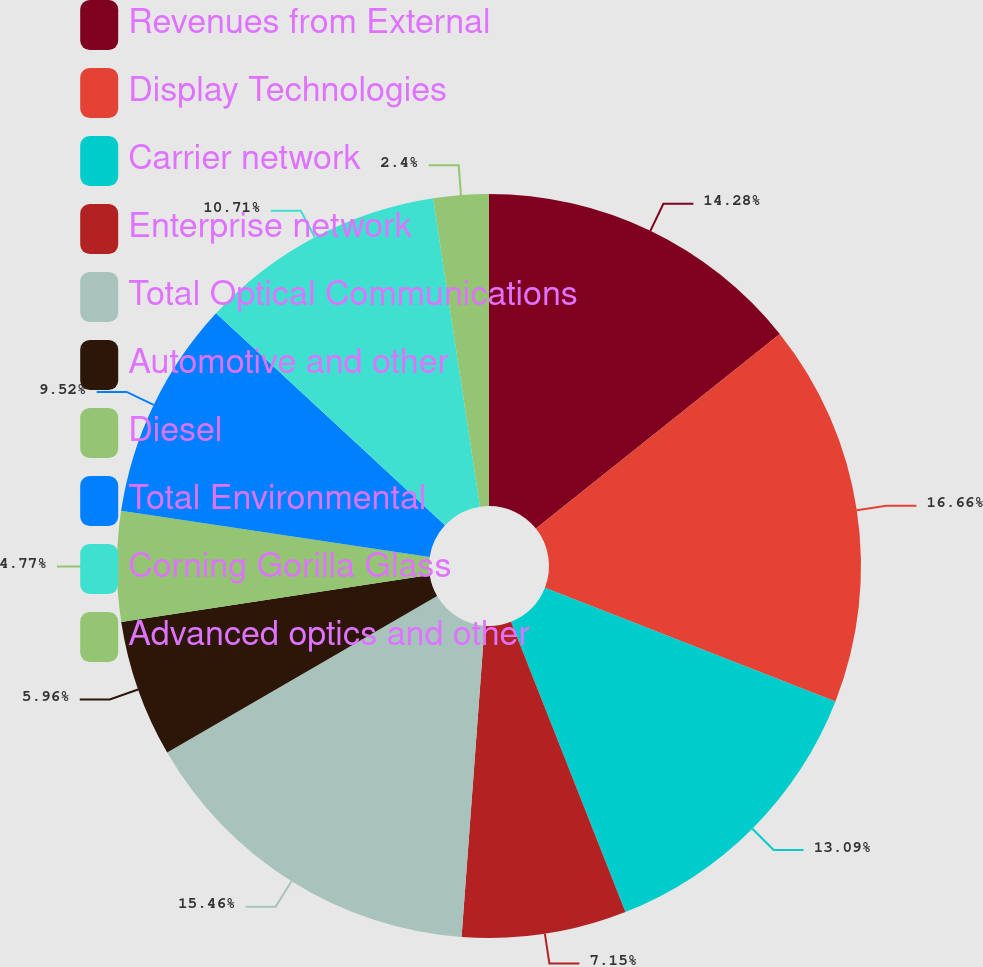Convert chart to OTSL. <chart><loc_0><loc_0><loc_500><loc_500><pie_chart><fcel>Revenues from External<fcel>Display Technologies<fcel>Carrier network<fcel>Enterprise network<fcel>Total Optical Communications<fcel>Automotive and other<fcel>Diesel<fcel>Total Environmental<fcel>Corning Gorilla Glass<fcel>Advanced optics and other<nl><fcel>14.28%<fcel>16.65%<fcel>13.09%<fcel>7.15%<fcel>15.46%<fcel>5.96%<fcel>4.77%<fcel>9.52%<fcel>10.71%<fcel>2.4%<nl></chart> 